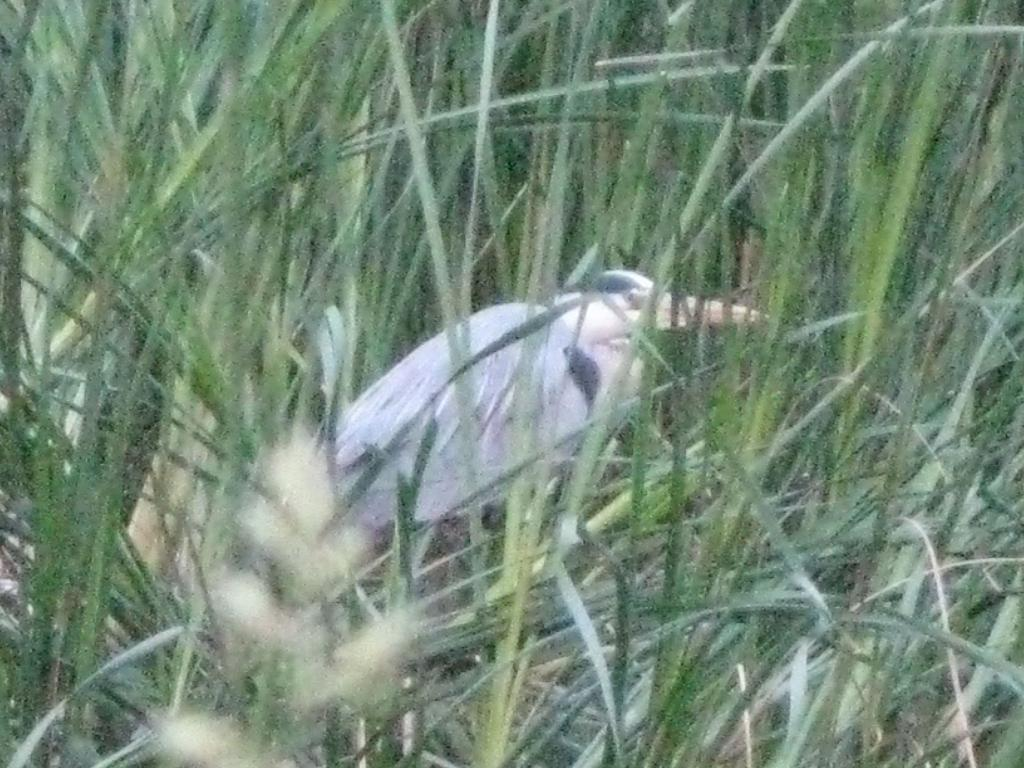Where was the image taken? The image was taken outdoors. What can be seen in the middle of the image? There is a bird in the middle of the image. What type of vegetation is visible in the image? There is grass visible in the image. What color is the button on the bird's wing in the image? There is no button present on the bird's wing in the image. How does the light affect the bird's appearance in the image? The image does not provide information about the lighting conditions, so it is impossible to determine how the light affects the bird's appearance. 